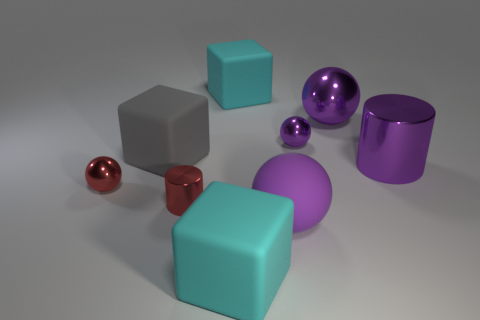What number of purple things are big rubber cylinders or large rubber spheres?
Your answer should be compact. 1. Are there fewer large gray matte cubes in front of the small cylinder than large cyan matte cubes that are in front of the large gray matte block?
Your answer should be very brief. Yes. Are there any cyan cubes of the same size as the purple matte object?
Keep it short and to the point. Yes. There is a cyan rubber thing that is behind the red shiny sphere; is its size the same as the red shiny sphere?
Provide a short and direct response. No. Are there more small red cylinders than cubes?
Your answer should be very brief. No. Are there any small purple metal things that have the same shape as the large purple matte object?
Your answer should be compact. Yes. There is a large cyan rubber thing that is in front of the big purple matte ball; what shape is it?
Provide a short and direct response. Cube. There is a purple metal object in front of the tiny metallic object that is right of the red cylinder; what number of cyan things are on the right side of it?
Your answer should be compact. 0. There is a sphere in front of the red ball; is its color the same as the big cylinder?
Your answer should be very brief. Yes. What number of other objects are the same shape as the purple rubber object?
Your response must be concise. 3. 